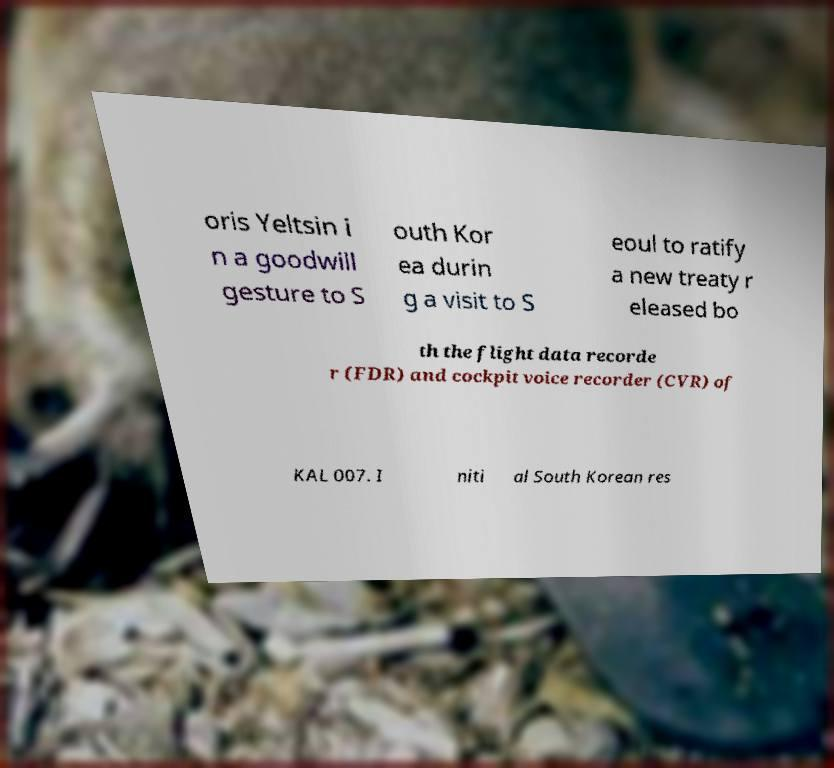There's text embedded in this image that I need extracted. Can you transcribe it verbatim? oris Yeltsin i n a goodwill gesture to S outh Kor ea durin g a visit to S eoul to ratify a new treaty r eleased bo th the flight data recorde r (FDR) and cockpit voice recorder (CVR) of KAL 007. I niti al South Korean res 